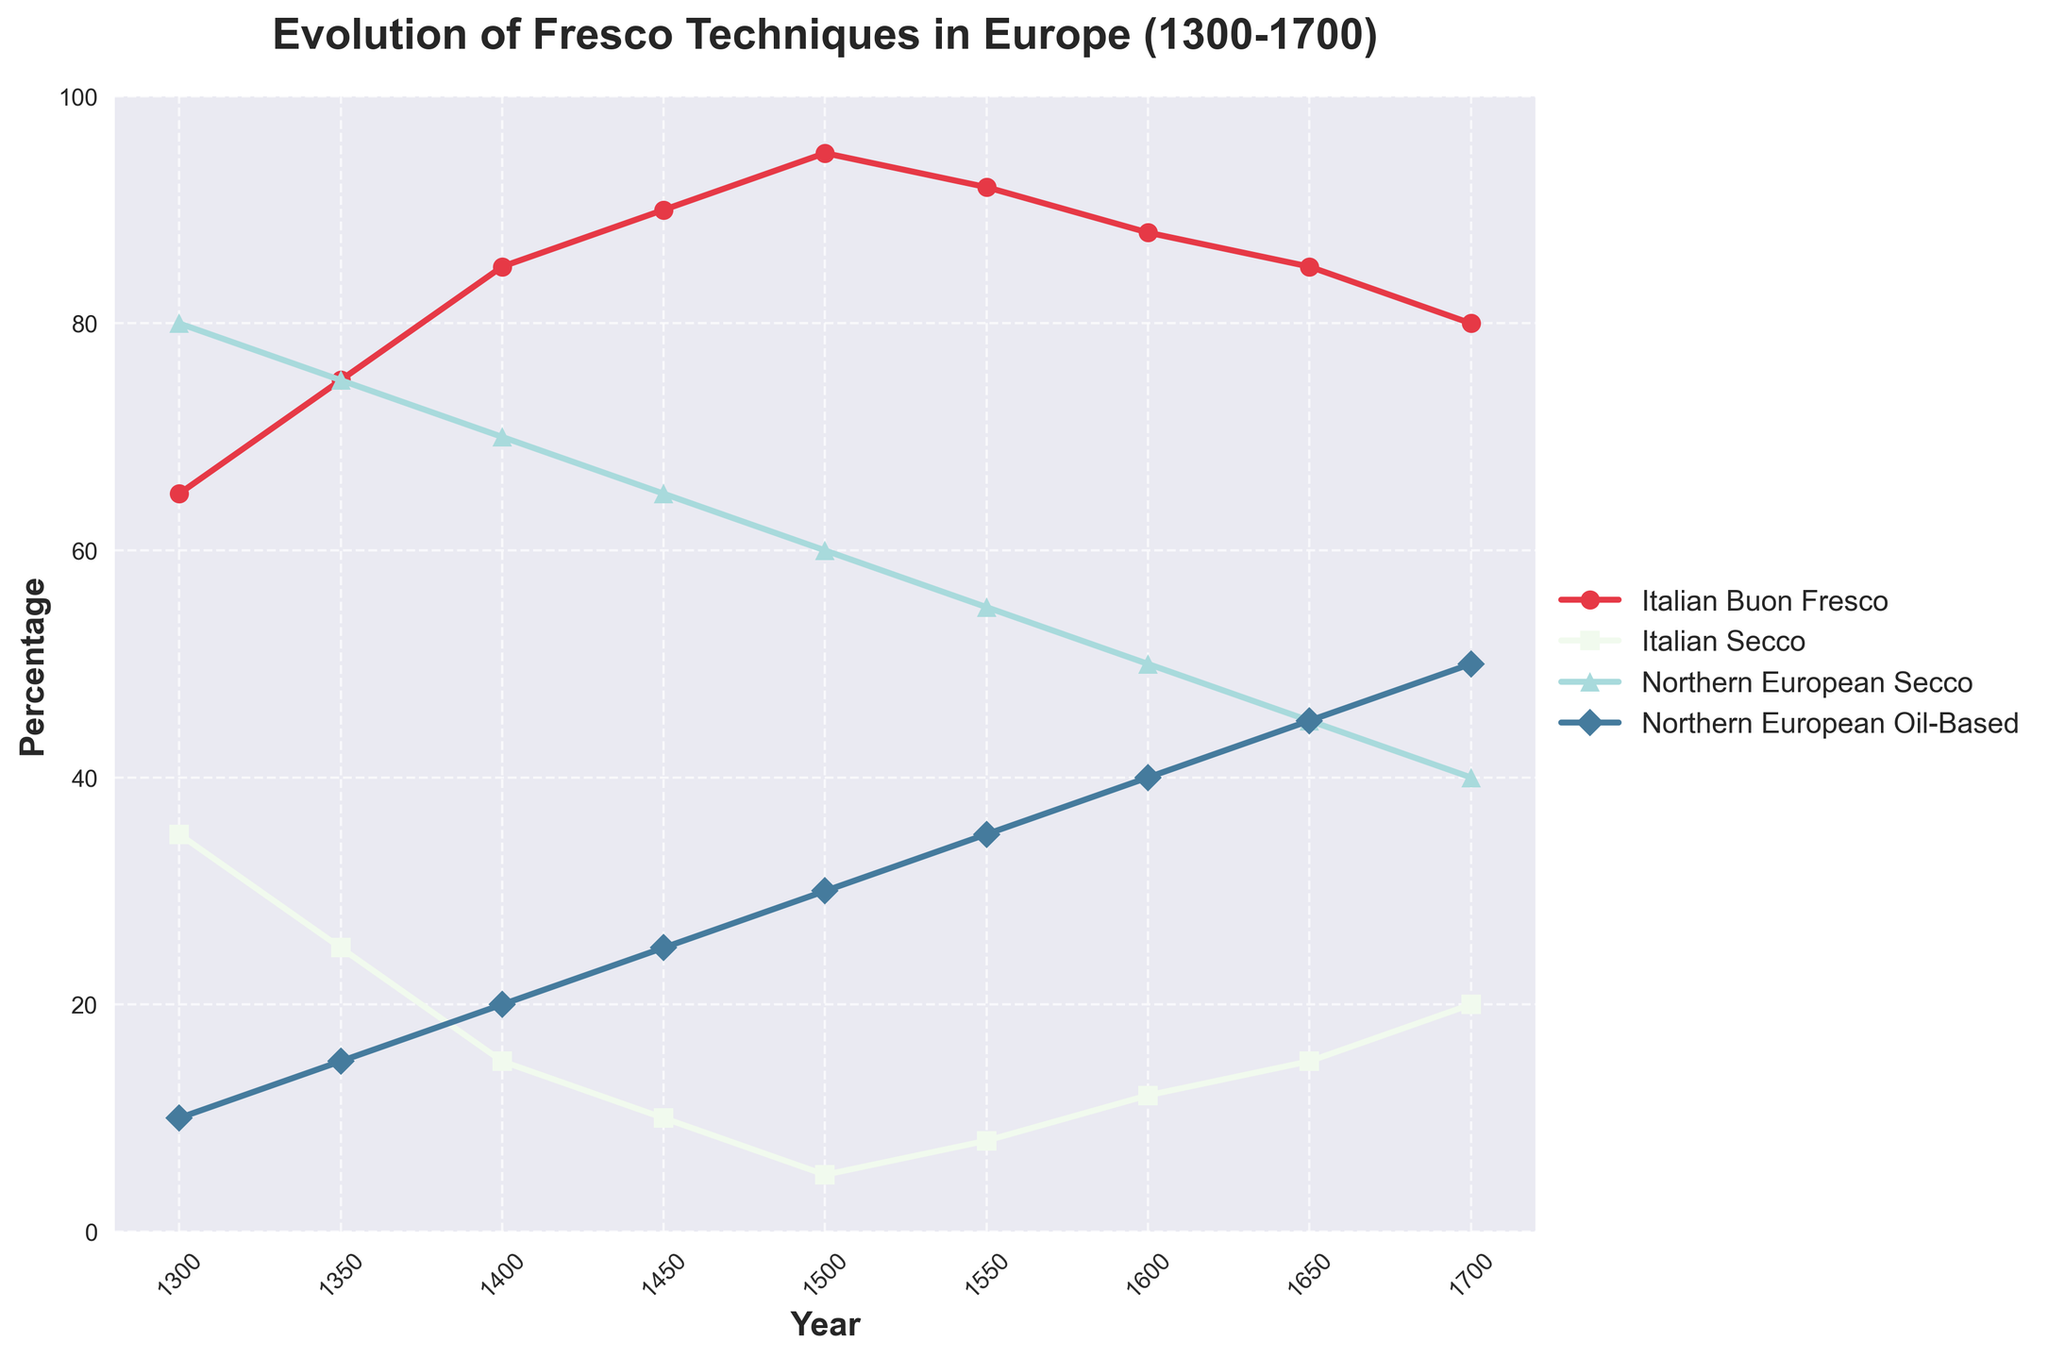Which technique had the highest percentage in 1500? By examining the 1500 data points on the y-axis, we see that "Italian Buon Fresco" reaches the highest percentage, clearly above other techniques.
Answer: Italian Buon Fresco Between 1400 and 1600, which Italian technique saw a significant drop? The "Italian Buon Fresco" line remains comparatively steady, while "Italian Secco" shows a reduction, implying the shift towards the former.
Answer: Italian Secco How does the percentage of Northern European Oil-Based painting in 1700 compare to its percentage in 1300? Comparing the values on the Y-axis at these years, Northern European Oil-Based painting rises from 10% in 1300 to 50% in 1700.
Answer: Increased by 40% Which Northern European technique was more prevalent in 1600, Secco or Oil-Based? In 1600, the percentage for Northern European Secco is 50% and for Oil-Based it's 40%, making Secco the more prevalent technique.
Answer: Secco What is the overall trend for Italian Buon Fresco from 1300 to 1700? Tracking the Italian Buon Fresco plot line, the percentage rises to a peak around 1500 and then shows a gradual decline.
Answer: Rises then declines Calculate the average percentage of Italian Secco in the entire period. Summing the percentages (35+25+15+10+5+8+12+15+20) gives 145, divided by 9 years gives approximately 16.1%.
Answer: 16.1% During which period did Northern European Oil-Based painting surpass 30%? This trend line crosses 30% between 1500 and 1550 and remains above thereafter.
Answer: 1550 Which style had a steady decline over the period depicted? Tracking Northern European Secco, it steadily declines from 80% in 1300 to 40% in 1700, unlike fluctuating others.
Answer: Northern European Secco 